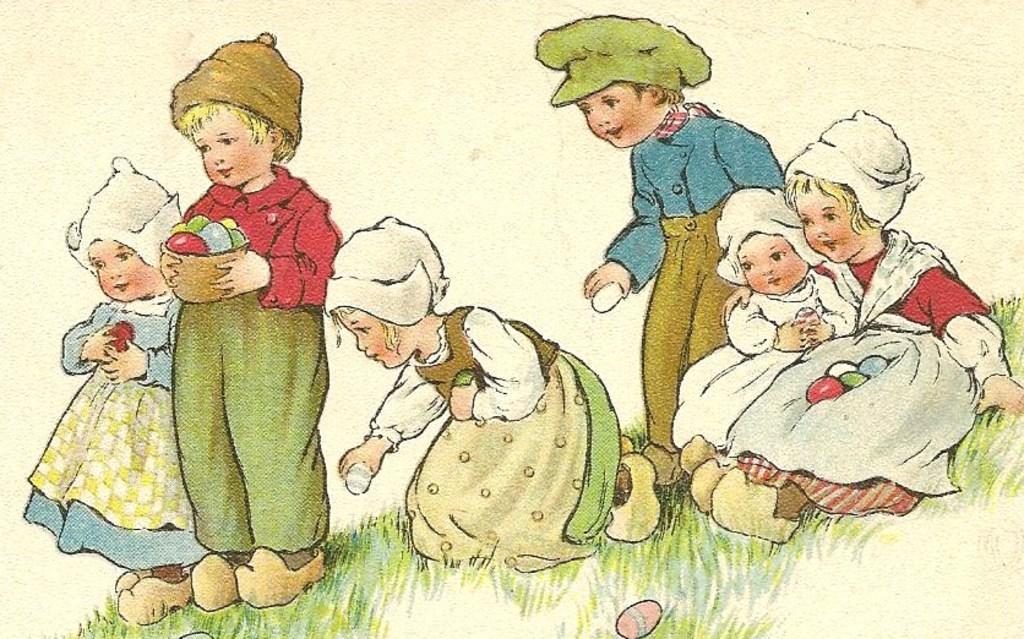Can you describe this image briefly? Here we can see a painting. This is grass and there are kids. And he is holding a bowl with his hands. 